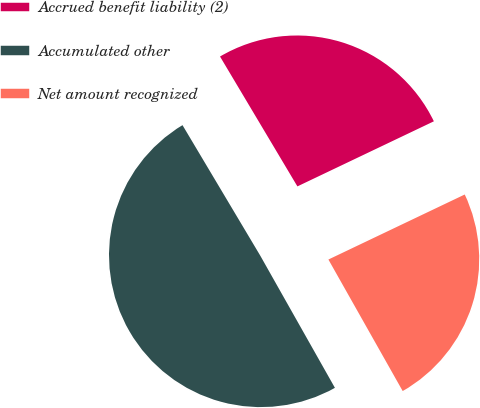Convert chart to OTSL. <chart><loc_0><loc_0><loc_500><loc_500><pie_chart><fcel>Accrued benefit liability (2)<fcel>Accumulated other<fcel>Net amount recognized<nl><fcel>26.47%<fcel>49.63%<fcel>23.9%<nl></chart> 